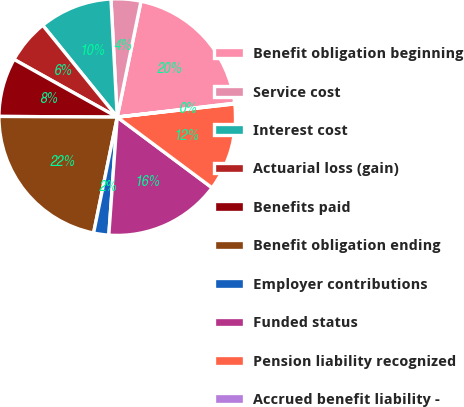Convert chart. <chart><loc_0><loc_0><loc_500><loc_500><pie_chart><fcel>Benefit obligation beginning<fcel>Service cost<fcel>Interest cost<fcel>Actuarial loss (gain)<fcel>Benefits paid<fcel>Benefit obligation ending<fcel>Employer contributions<fcel>Funded status<fcel>Pension liability recognized<fcel>Accrued benefit liability -<nl><fcel>19.91%<fcel>4.06%<fcel>10.0%<fcel>6.04%<fcel>8.02%<fcel>21.89%<fcel>2.07%<fcel>15.94%<fcel>11.98%<fcel>0.09%<nl></chart> 